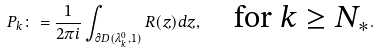Convert formula to latex. <formula><loc_0><loc_0><loc_500><loc_500>P _ { k } \colon = \frac { 1 } { 2 \pi i } \int _ { \partial D ( \lambda ^ { 0 } _ { k } , 1 ) } R ( z ) d z , \quad \text {for $k\geq N_{*}$} .</formula> 